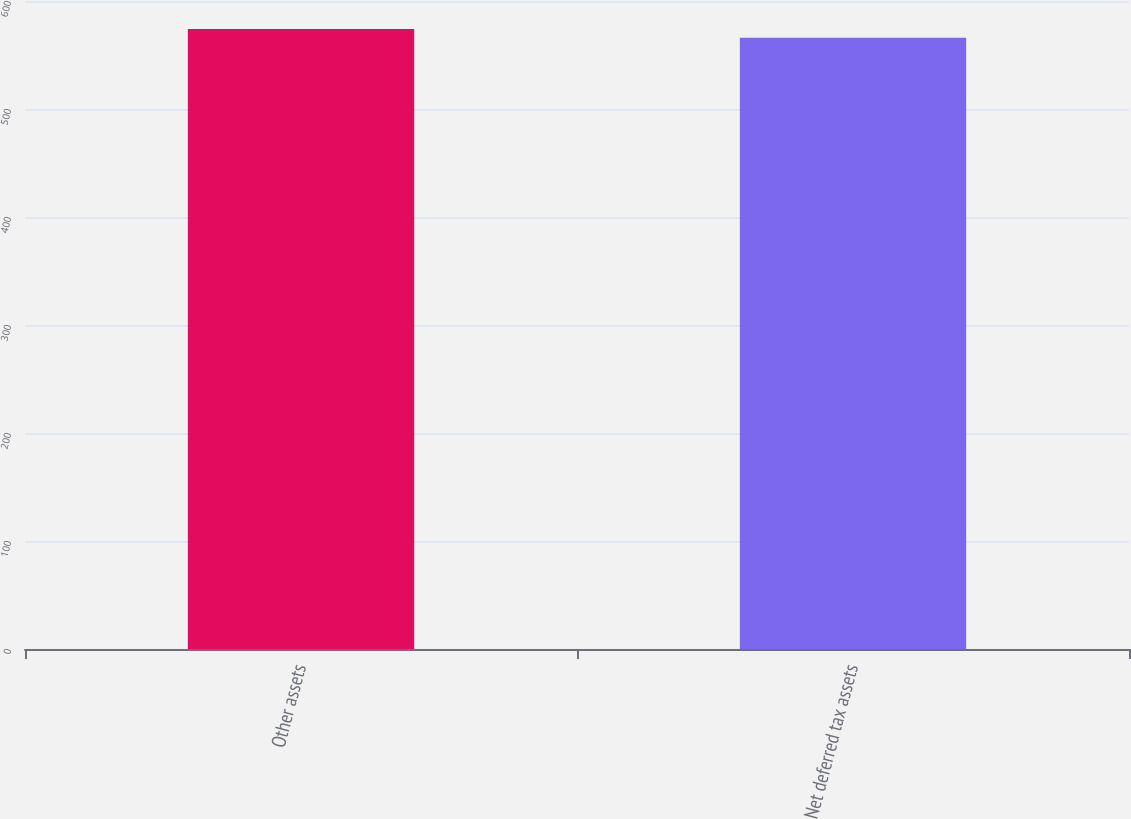Convert chart to OTSL. <chart><loc_0><loc_0><loc_500><loc_500><bar_chart><fcel>Other assets<fcel>Net deferred tax assets<nl><fcel>574<fcel>566<nl></chart> 